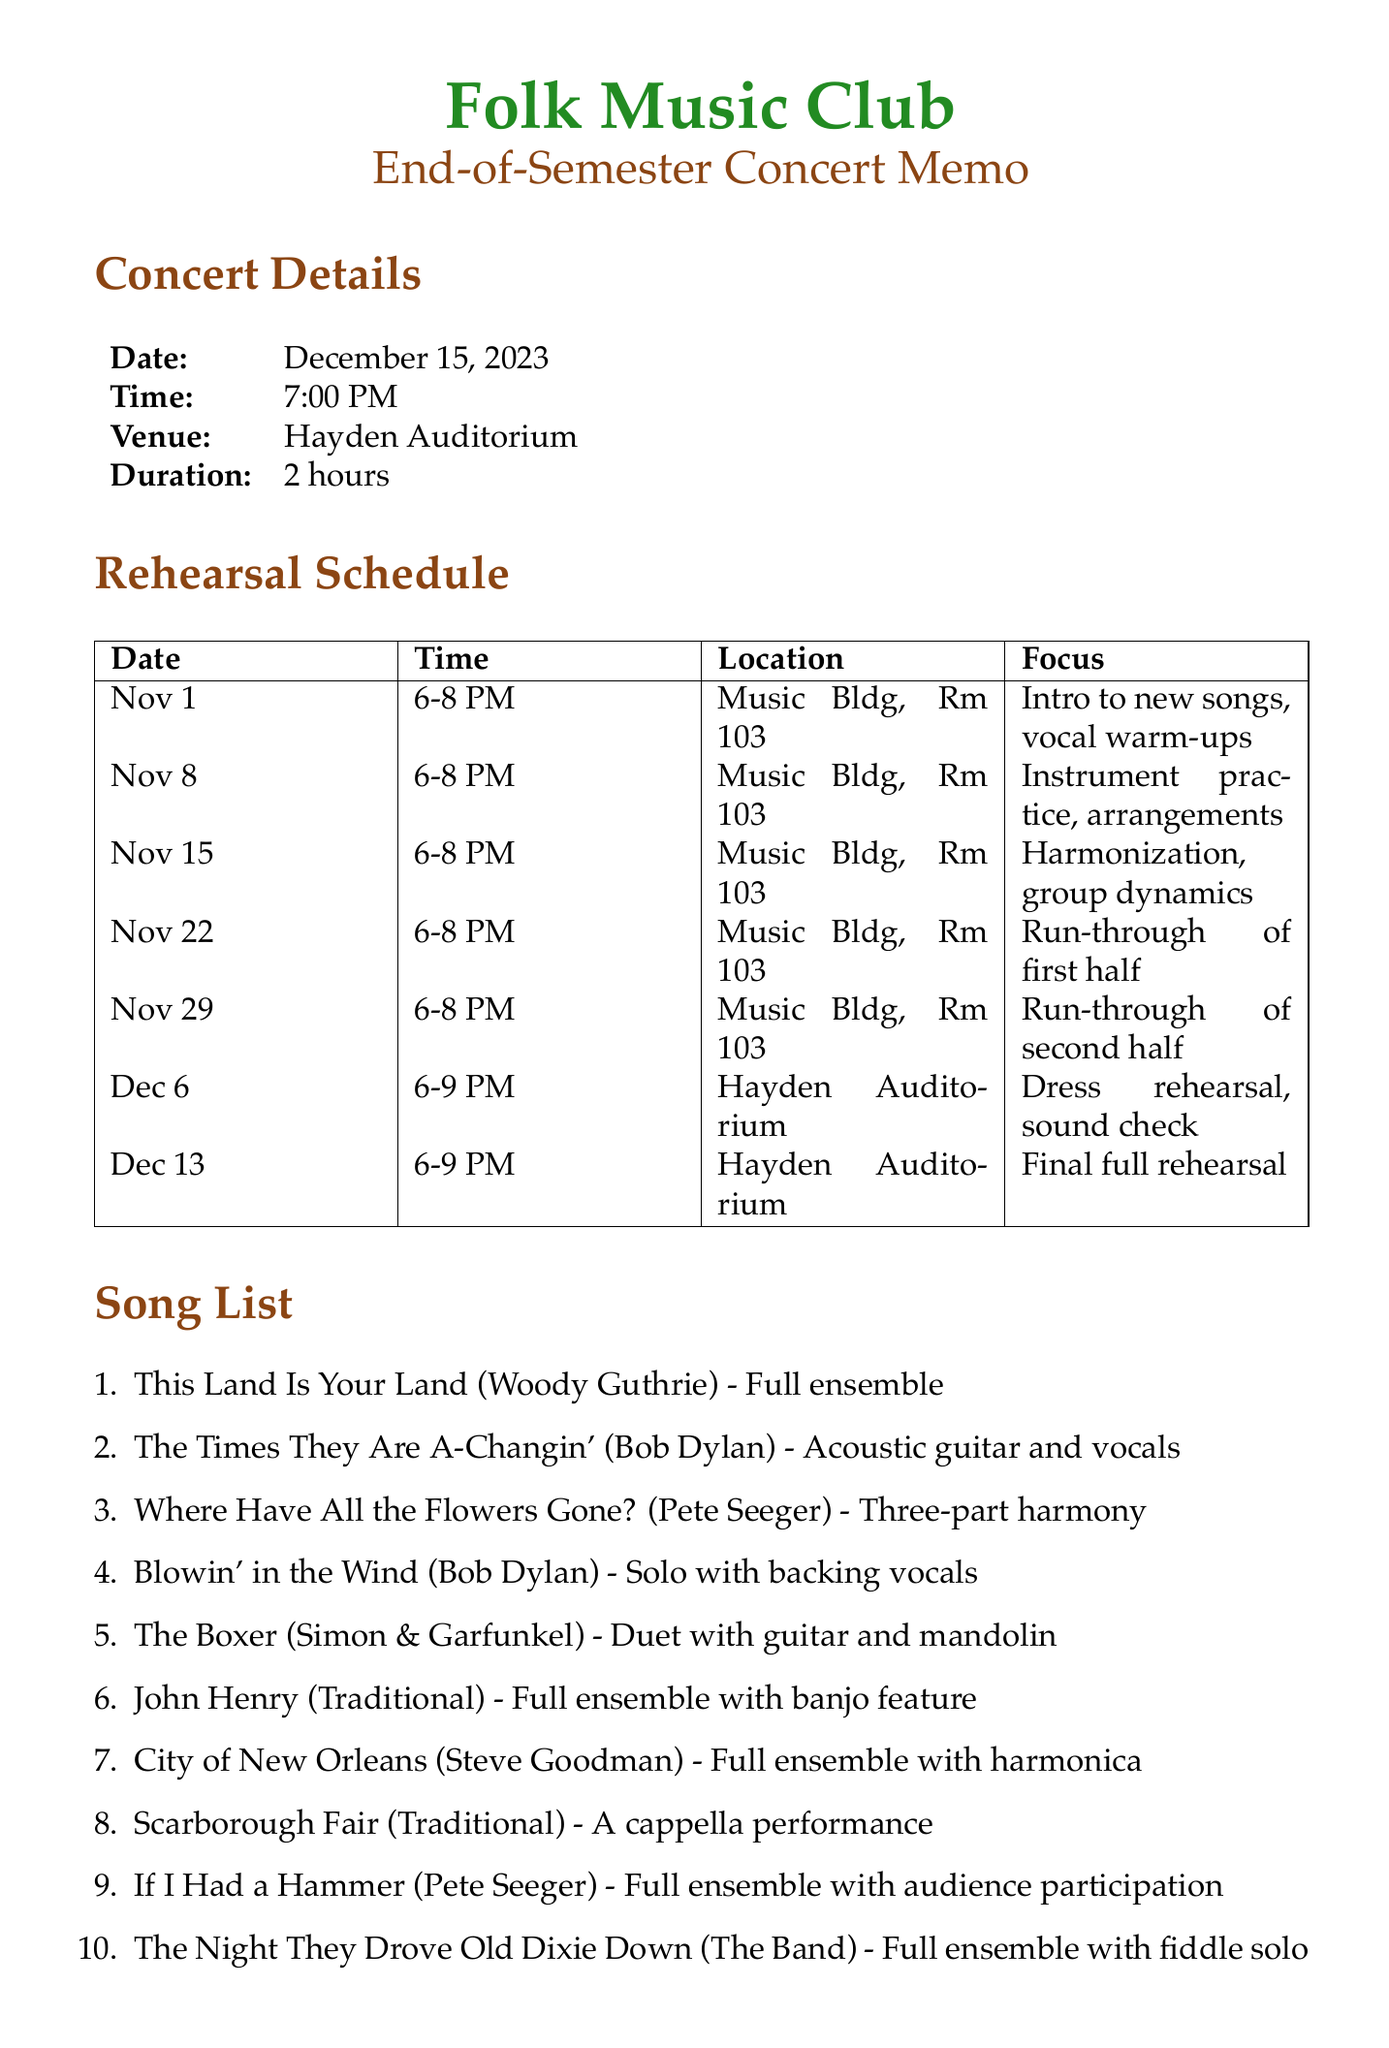What is the concert date? The concert date is explicitly mentioned in the document under concert details.
Answer: December 15, 2023 What location is designated for the dress rehearsal? The dress rehearsal's location is specified in the rehearsal schedule section.
Answer: Hayden Auditorium Who is the Vice President of the club? The club officers' section lists the names and positions of the officers.
Answer: Michael Chen How many rehearsals must club members attend at minimum? The additional notes provide guidance on attendance requirements.
Answer: 5 What is the arrangement type for "Scarborough Fair"? This information is found in the song list section detailing arrangements for each song.
Answer: A cappella performance What time does the final rehearsal start? The time for the final rehearsal is stated in the rehearsal schedule.
Answer: 6:00 PM What is the duration of the concert? The concert duration is specified in the concert details section.
Answer: 2 hours What focus is scheduled for the rehearsal on November 15? The specific focus for that date is indicated in the rehearsal schedule.
Answer: Harmonization and group dynamics Which song features a fiddle solo in the arrangement? The song list gives details about each song, including unique features for the arrangements.
Answer: The Night They Drove Old Dixie Down 